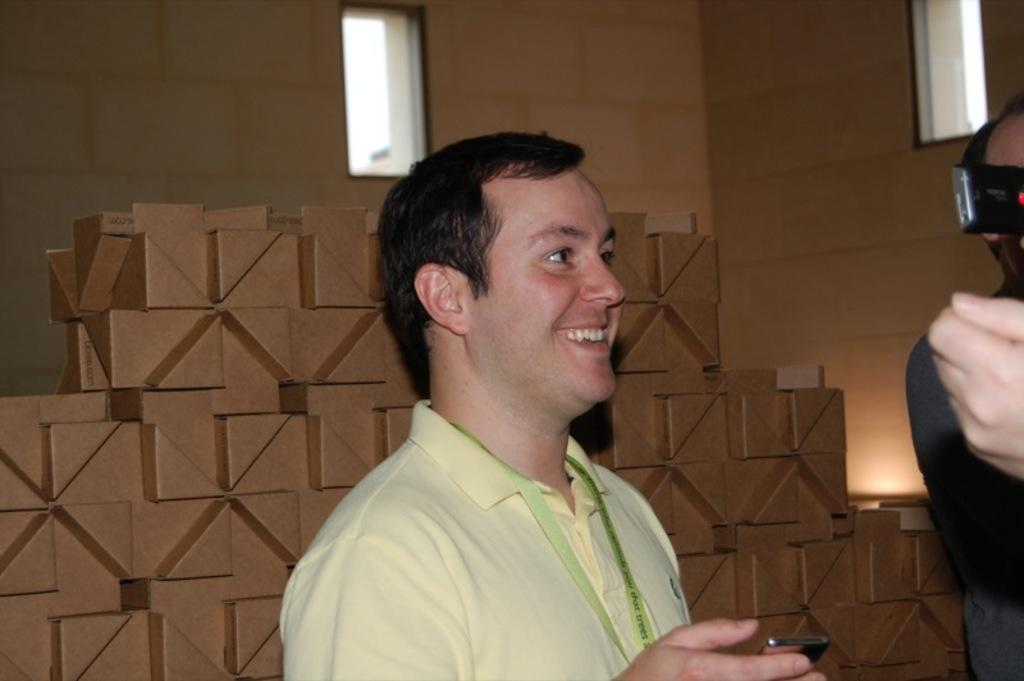What is happening in the image involving the people? There are people standing in the image. Can you describe the expression of one of the individuals? A man is smiling in the image. What is the man holding in the image? The man is holding a mobile. What can be seen in the background of the image? There is a wall and windows in the background of the image. What type of work is the man doing with the mobile in the image? The man is not shown doing any work with the mobile in the image; he is simply holding it. How does the man rub the windows in the background of the image? The man is not rubbing the windows in the background of the image; he is standing in front of them. 